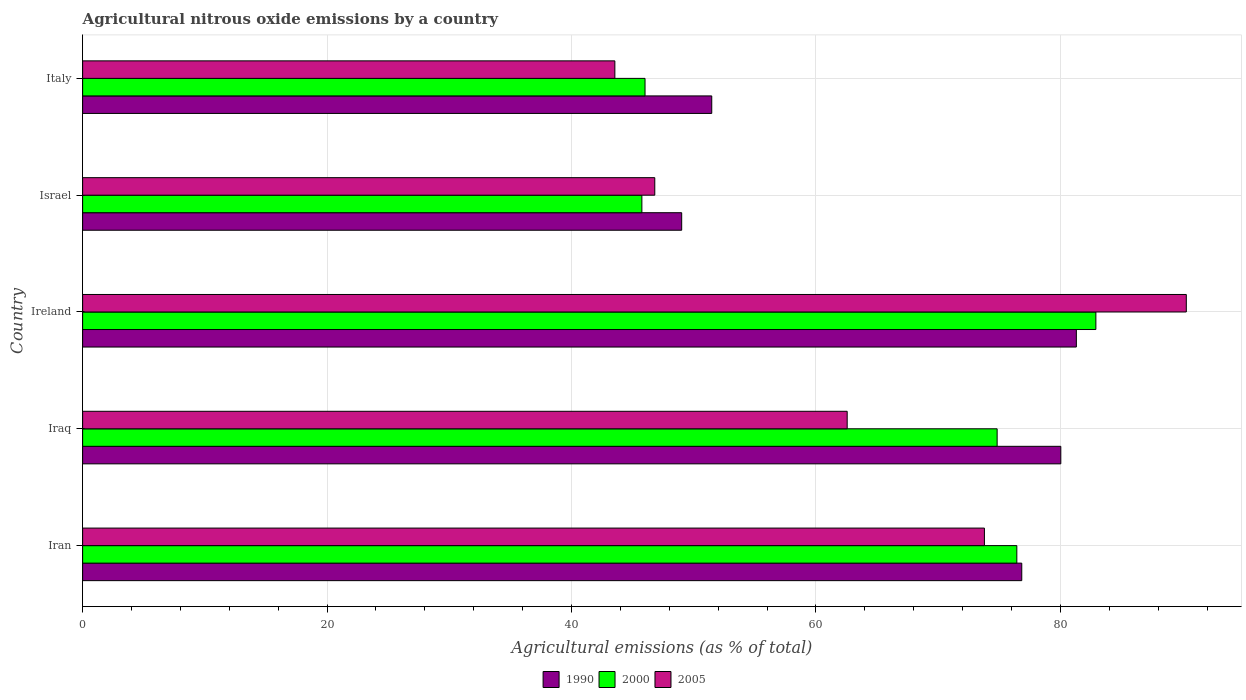How many different coloured bars are there?
Keep it short and to the point. 3. How many bars are there on the 3rd tick from the bottom?
Offer a very short reply. 3. What is the label of the 3rd group of bars from the top?
Ensure brevity in your answer.  Ireland. In how many cases, is the number of bars for a given country not equal to the number of legend labels?
Your answer should be compact. 0. What is the amount of agricultural nitrous oxide emitted in 1990 in Ireland?
Your answer should be very brief. 81.31. Across all countries, what is the maximum amount of agricultural nitrous oxide emitted in 2000?
Offer a very short reply. 82.91. Across all countries, what is the minimum amount of agricultural nitrous oxide emitted in 1990?
Your answer should be very brief. 49.02. In which country was the amount of agricultural nitrous oxide emitted in 2000 maximum?
Provide a succinct answer. Ireland. In which country was the amount of agricultural nitrous oxide emitted in 1990 minimum?
Your answer should be compact. Israel. What is the total amount of agricultural nitrous oxide emitted in 2000 in the graph?
Give a very brief answer. 325.96. What is the difference between the amount of agricultural nitrous oxide emitted in 2000 in Iraq and that in Israel?
Offer a very short reply. 29.07. What is the difference between the amount of agricultural nitrous oxide emitted in 2000 in Italy and the amount of agricultural nitrous oxide emitted in 2005 in Iran?
Your response must be concise. -27.77. What is the average amount of agricultural nitrous oxide emitted in 1990 per country?
Offer a very short reply. 67.74. What is the difference between the amount of agricultural nitrous oxide emitted in 2000 and amount of agricultural nitrous oxide emitted in 1990 in Iran?
Offer a very short reply. -0.4. In how many countries, is the amount of agricultural nitrous oxide emitted in 2000 greater than 24 %?
Give a very brief answer. 5. What is the ratio of the amount of agricultural nitrous oxide emitted in 2005 in Iran to that in Ireland?
Offer a terse response. 0.82. What is the difference between the highest and the second highest amount of agricultural nitrous oxide emitted in 1990?
Provide a succinct answer. 1.27. What is the difference between the highest and the lowest amount of agricultural nitrous oxide emitted in 1990?
Your response must be concise. 32.29. In how many countries, is the amount of agricultural nitrous oxide emitted in 2000 greater than the average amount of agricultural nitrous oxide emitted in 2000 taken over all countries?
Provide a short and direct response. 3. Are all the bars in the graph horizontal?
Offer a terse response. Yes. What is the difference between two consecutive major ticks on the X-axis?
Your response must be concise. 20. Are the values on the major ticks of X-axis written in scientific E-notation?
Provide a short and direct response. No. Does the graph contain any zero values?
Offer a very short reply. No. Does the graph contain grids?
Provide a succinct answer. Yes. How are the legend labels stacked?
Provide a succinct answer. Horizontal. What is the title of the graph?
Provide a short and direct response. Agricultural nitrous oxide emissions by a country. What is the label or title of the X-axis?
Your answer should be very brief. Agricultural emissions (as % of total). What is the label or title of the Y-axis?
Your answer should be very brief. Country. What is the Agricultural emissions (as % of total) of 1990 in Iran?
Provide a short and direct response. 76.84. What is the Agricultural emissions (as % of total) in 2000 in Iran?
Your response must be concise. 76.44. What is the Agricultural emissions (as % of total) of 2005 in Iran?
Give a very brief answer. 73.79. What is the Agricultural emissions (as % of total) of 1990 in Iraq?
Provide a short and direct response. 80.04. What is the Agricultural emissions (as % of total) in 2000 in Iraq?
Your answer should be very brief. 74.83. What is the Agricultural emissions (as % of total) of 2005 in Iraq?
Provide a succinct answer. 62.56. What is the Agricultural emissions (as % of total) in 1990 in Ireland?
Your response must be concise. 81.31. What is the Agricultural emissions (as % of total) in 2000 in Ireland?
Provide a succinct answer. 82.91. What is the Agricultural emissions (as % of total) in 2005 in Ireland?
Your answer should be very brief. 90.31. What is the Agricultural emissions (as % of total) of 1990 in Israel?
Offer a very short reply. 49.02. What is the Agricultural emissions (as % of total) of 2000 in Israel?
Provide a short and direct response. 45.76. What is the Agricultural emissions (as % of total) in 2005 in Israel?
Make the answer very short. 46.82. What is the Agricultural emissions (as % of total) in 1990 in Italy?
Your response must be concise. 51.48. What is the Agricultural emissions (as % of total) in 2000 in Italy?
Provide a short and direct response. 46.02. What is the Agricultural emissions (as % of total) of 2005 in Italy?
Offer a terse response. 43.55. Across all countries, what is the maximum Agricultural emissions (as % of total) in 1990?
Provide a succinct answer. 81.31. Across all countries, what is the maximum Agricultural emissions (as % of total) of 2000?
Offer a terse response. 82.91. Across all countries, what is the maximum Agricultural emissions (as % of total) of 2005?
Offer a very short reply. 90.31. Across all countries, what is the minimum Agricultural emissions (as % of total) in 1990?
Your response must be concise. 49.02. Across all countries, what is the minimum Agricultural emissions (as % of total) of 2000?
Make the answer very short. 45.76. Across all countries, what is the minimum Agricultural emissions (as % of total) of 2005?
Your answer should be compact. 43.55. What is the total Agricultural emissions (as % of total) of 1990 in the graph?
Your answer should be compact. 338.69. What is the total Agricultural emissions (as % of total) in 2000 in the graph?
Give a very brief answer. 325.96. What is the total Agricultural emissions (as % of total) of 2005 in the graph?
Make the answer very short. 317.02. What is the difference between the Agricultural emissions (as % of total) of 1990 in Iran and that in Iraq?
Your answer should be very brief. -3.19. What is the difference between the Agricultural emissions (as % of total) in 2000 in Iran and that in Iraq?
Your answer should be compact. 1.61. What is the difference between the Agricultural emissions (as % of total) in 2005 in Iran and that in Iraq?
Offer a terse response. 11.23. What is the difference between the Agricultural emissions (as % of total) in 1990 in Iran and that in Ireland?
Your response must be concise. -4.47. What is the difference between the Agricultural emissions (as % of total) in 2000 in Iran and that in Ireland?
Your answer should be compact. -6.47. What is the difference between the Agricultural emissions (as % of total) in 2005 in Iran and that in Ireland?
Ensure brevity in your answer.  -16.52. What is the difference between the Agricultural emissions (as % of total) in 1990 in Iran and that in Israel?
Ensure brevity in your answer.  27.83. What is the difference between the Agricultural emissions (as % of total) of 2000 in Iran and that in Israel?
Ensure brevity in your answer.  30.68. What is the difference between the Agricultural emissions (as % of total) in 2005 in Iran and that in Israel?
Provide a succinct answer. 26.97. What is the difference between the Agricultural emissions (as % of total) in 1990 in Iran and that in Italy?
Provide a short and direct response. 25.37. What is the difference between the Agricultural emissions (as % of total) of 2000 in Iran and that in Italy?
Offer a terse response. 30.42. What is the difference between the Agricultural emissions (as % of total) of 2005 in Iran and that in Italy?
Provide a succinct answer. 30.24. What is the difference between the Agricultural emissions (as % of total) in 1990 in Iraq and that in Ireland?
Give a very brief answer. -1.27. What is the difference between the Agricultural emissions (as % of total) in 2000 in Iraq and that in Ireland?
Offer a very short reply. -8.08. What is the difference between the Agricultural emissions (as % of total) of 2005 in Iraq and that in Ireland?
Provide a short and direct response. -27.75. What is the difference between the Agricultural emissions (as % of total) in 1990 in Iraq and that in Israel?
Make the answer very short. 31.02. What is the difference between the Agricultural emissions (as % of total) in 2000 in Iraq and that in Israel?
Your answer should be compact. 29.07. What is the difference between the Agricultural emissions (as % of total) in 2005 in Iraq and that in Israel?
Provide a short and direct response. 15.74. What is the difference between the Agricultural emissions (as % of total) in 1990 in Iraq and that in Italy?
Make the answer very short. 28.56. What is the difference between the Agricultural emissions (as % of total) of 2000 in Iraq and that in Italy?
Provide a short and direct response. 28.81. What is the difference between the Agricultural emissions (as % of total) in 2005 in Iraq and that in Italy?
Provide a short and direct response. 19.01. What is the difference between the Agricultural emissions (as % of total) of 1990 in Ireland and that in Israel?
Your answer should be very brief. 32.29. What is the difference between the Agricultural emissions (as % of total) in 2000 in Ireland and that in Israel?
Keep it short and to the point. 37.15. What is the difference between the Agricultural emissions (as % of total) of 2005 in Ireland and that in Israel?
Keep it short and to the point. 43.49. What is the difference between the Agricultural emissions (as % of total) of 1990 in Ireland and that in Italy?
Keep it short and to the point. 29.83. What is the difference between the Agricultural emissions (as % of total) in 2000 in Ireland and that in Italy?
Your answer should be compact. 36.89. What is the difference between the Agricultural emissions (as % of total) of 2005 in Ireland and that in Italy?
Your response must be concise. 46.76. What is the difference between the Agricultural emissions (as % of total) of 1990 in Israel and that in Italy?
Your answer should be compact. -2.46. What is the difference between the Agricultural emissions (as % of total) in 2000 in Israel and that in Italy?
Keep it short and to the point. -0.26. What is the difference between the Agricultural emissions (as % of total) in 2005 in Israel and that in Italy?
Offer a very short reply. 3.27. What is the difference between the Agricultural emissions (as % of total) of 1990 in Iran and the Agricultural emissions (as % of total) of 2000 in Iraq?
Your answer should be compact. 2.02. What is the difference between the Agricultural emissions (as % of total) in 1990 in Iran and the Agricultural emissions (as % of total) in 2005 in Iraq?
Your answer should be compact. 14.29. What is the difference between the Agricultural emissions (as % of total) in 2000 in Iran and the Agricultural emissions (as % of total) in 2005 in Iraq?
Offer a terse response. 13.88. What is the difference between the Agricultural emissions (as % of total) of 1990 in Iran and the Agricultural emissions (as % of total) of 2000 in Ireland?
Keep it short and to the point. -6.06. What is the difference between the Agricultural emissions (as % of total) in 1990 in Iran and the Agricultural emissions (as % of total) in 2005 in Ireland?
Offer a very short reply. -13.46. What is the difference between the Agricultural emissions (as % of total) of 2000 in Iran and the Agricultural emissions (as % of total) of 2005 in Ireland?
Your response must be concise. -13.87. What is the difference between the Agricultural emissions (as % of total) in 1990 in Iran and the Agricultural emissions (as % of total) in 2000 in Israel?
Provide a succinct answer. 31.08. What is the difference between the Agricultural emissions (as % of total) of 1990 in Iran and the Agricultural emissions (as % of total) of 2005 in Israel?
Your answer should be compact. 30.03. What is the difference between the Agricultural emissions (as % of total) in 2000 in Iran and the Agricultural emissions (as % of total) in 2005 in Israel?
Make the answer very short. 29.62. What is the difference between the Agricultural emissions (as % of total) in 1990 in Iran and the Agricultural emissions (as % of total) in 2000 in Italy?
Keep it short and to the point. 30.83. What is the difference between the Agricultural emissions (as % of total) in 1990 in Iran and the Agricultural emissions (as % of total) in 2005 in Italy?
Keep it short and to the point. 33.3. What is the difference between the Agricultural emissions (as % of total) in 2000 in Iran and the Agricultural emissions (as % of total) in 2005 in Italy?
Your answer should be compact. 32.89. What is the difference between the Agricultural emissions (as % of total) in 1990 in Iraq and the Agricultural emissions (as % of total) in 2000 in Ireland?
Keep it short and to the point. -2.87. What is the difference between the Agricultural emissions (as % of total) of 1990 in Iraq and the Agricultural emissions (as % of total) of 2005 in Ireland?
Your response must be concise. -10.27. What is the difference between the Agricultural emissions (as % of total) in 2000 in Iraq and the Agricultural emissions (as % of total) in 2005 in Ireland?
Offer a very short reply. -15.48. What is the difference between the Agricultural emissions (as % of total) of 1990 in Iraq and the Agricultural emissions (as % of total) of 2000 in Israel?
Give a very brief answer. 34.28. What is the difference between the Agricultural emissions (as % of total) in 1990 in Iraq and the Agricultural emissions (as % of total) in 2005 in Israel?
Make the answer very short. 33.22. What is the difference between the Agricultural emissions (as % of total) in 2000 in Iraq and the Agricultural emissions (as % of total) in 2005 in Israel?
Make the answer very short. 28.01. What is the difference between the Agricultural emissions (as % of total) in 1990 in Iraq and the Agricultural emissions (as % of total) in 2000 in Italy?
Keep it short and to the point. 34.02. What is the difference between the Agricultural emissions (as % of total) in 1990 in Iraq and the Agricultural emissions (as % of total) in 2005 in Italy?
Provide a succinct answer. 36.49. What is the difference between the Agricultural emissions (as % of total) of 2000 in Iraq and the Agricultural emissions (as % of total) of 2005 in Italy?
Ensure brevity in your answer.  31.28. What is the difference between the Agricultural emissions (as % of total) of 1990 in Ireland and the Agricultural emissions (as % of total) of 2000 in Israel?
Keep it short and to the point. 35.55. What is the difference between the Agricultural emissions (as % of total) in 1990 in Ireland and the Agricultural emissions (as % of total) in 2005 in Israel?
Your answer should be very brief. 34.49. What is the difference between the Agricultural emissions (as % of total) of 2000 in Ireland and the Agricultural emissions (as % of total) of 2005 in Israel?
Your answer should be compact. 36.09. What is the difference between the Agricultural emissions (as % of total) of 1990 in Ireland and the Agricultural emissions (as % of total) of 2000 in Italy?
Offer a very short reply. 35.29. What is the difference between the Agricultural emissions (as % of total) of 1990 in Ireland and the Agricultural emissions (as % of total) of 2005 in Italy?
Provide a succinct answer. 37.76. What is the difference between the Agricultural emissions (as % of total) of 2000 in Ireland and the Agricultural emissions (as % of total) of 2005 in Italy?
Keep it short and to the point. 39.36. What is the difference between the Agricultural emissions (as % of total) in 1990 in Israel and the Agricultural emissions (as % of total) in 2000 in Italy?
Give a very brief answer. 3. What is the difference between the Agricultural emissions (as % of total) in 1990 in Israel and the Agricultural emissions (as % of total) in 2005 in Italy?
Offer a terse response. 5.47. What is the difference between the Agricultural emissions (as % of total) of 2000 in Israel and the Agricultural emissions (as % of total) of 2005 in Italy?
Offer a terse response. 2.21. What is the average Agricultural emissions (as % of total) of 1990 per country?
Provide a short and direct response. 67.74. What is the average Agricultural emissions (as % of total) in 2000 per country?
Your answer should be compact. 65.19. What is the average Agricultural emissions (as % of total) of 2005 per country?
Your response must be concise. 63.4. What is the difference between the Agricultural emissions (as % of total) in 1990 and Agricultural emissions (as % of total) in 2000 in Iran?
Make the answer very short. 0.4. What is the difference between the Agricultural emissions (as % of total) in 1990 and Agricultural emissions (as % of total) in 2005 in Iran?
Your answer should be very brief. 3.06. What is the difference between the Agricultural emissions (as % of total) of 2000 and Agricultural emissions (as % of total) of 2005 in Iran?
Provide a succinct answer. 2.65. What is the difference between the Agricultural emissions (as % of total) of 1990 and Agricultural emissions (as % of total) of 2000 in Iraq?
Make the answer very short. 5.21. What is the difference between the Agricultural emissions (as % of total) of 1990 and Agricultural emissions (as % of total) of 2005 in Iraq?
Give a very brief answer. 17.48. What is the difference between the Agricultural emissions (as % of total) in 2000 and Agricultural emissions (as % of total) in 2005 in Iraq?
Your answer should be very brief. 12.27. What is the difference between the Agricultural emissions (as % of total) in 1990 and Agricultural emissions (as % of total) in 2000 in Ireland?
Offer a very short reply. -1.6. What is the difference between the Agricultural emissions (as % of total) in 1990 and Agricultural emissions (as % of total) in 2005 in Ireland?
Provide a succinct answer. -9. What is the difference between the Agricultural emissions (as % of total) of 2000 and Agricultural emissions (as % of total) of 2005 in Ireland?
Provide a succinct answer. -7.4. What is the difference between the Agricultural emissions (as % of total) of 1990 and Agricultural emissions (as % of total) of 2000 in Israel?
Provide a succinct answer. 3.26. What is the difference between the Agricultural emissions (as % of total) of 1990 and Agricultural emissions (as % of total) of 2005 in Israel?
Offer a terse response. 2.2. What is the difference between the Agricultural emissions (as % of total) in 2000 and Agricultural emissions (as % of total) in 2005 in Israel?
Your answer should be compact. -1.06. What is the difference between the Agricultural emissions (as % of total) in 1990 and Agricultural emissions (as % of total) in 2000 in Italy?
Offer a very short reply. 5.46. What is the difference between the Agricultural emissions (as % of total) of 1990 and Agricultural emissions (as % of total) of 2005 in Italy?
Give a very brief answer. 7.93. What is the difference between the Agricultural emissions (as % of total) in 2000 and Agricultural emissions (as % of total) in 2005 in Italy?
Give a very brief answer. 2.47. What is the ratio of the Agricultural emissions (as % of total) of 1990 in Iran to that in Iraq?
Offer a very short reply. 0.96. What is the ratio of the Agricultural emissions (as % of total) of 2000 in Iran to that in Iraq?
Keep it short and to the point. 1.02. What is the ratio of the Agricultural emissions (as % of total) of 2005 in Iran to that in Iraq?
Keep it short and to the point. 1.18. What is the ratio of the Agricultural emissions (as % of total) of 1990 in Iran to that in Ireland?
Your answer should be very brief. 0.95. What is the ratio of the Agricultural emissions (as % of total) of 2000 in Iran to that in Ireland?
Your answer should be compact. 0.92. What is the ratio of the Agricultural emissions (as % of total) of 2005 in Iran to that in Ireland?
Your answer should be compact. 0.82. What is the ratio of the Agricultural emissions (as % of total) of 1990 in Iran to that in Israel?
Your answer should be compact. 1.57. What is the ratio of the Agricultural emissions (as % of total) in 2000 in Iran to that in Israel?
Ensure brevity in your answer.  1.67. What is the ratio of the Agricultural emissions (as % of total) in 2005 in Iran to that in Israel?
Give a very brief answer. 1.58. What is the ratio of the Agricultural emissions (as % of total) of 1990 in Iran to that in Italy?
Provide a succinct answer. 1.49. What is the ratio of the Agricultural emissions (as % of total) in 2000 in Iran to that in Italy?
Make the answer very short. 1.66. What is the ratio of the Agricultural emissions (as % of total) of 2005 in Iran to that in Italy?
Provide a succinct answer. 1.69. What is the ratio of the Agricultural emissions (as % of total) in 1990 in Iraq to that in Ireland?
Give a very brief answer. 0.98. What is the ratio of the Agricultural emissions (as % of total) in 2000 in Iraq to that in Ireland?
Provide a succinct answer. 0.9. What is the ratio of the Agricultural emissions (as % of total) in 2005 in Iraq to that in Ireland?
Offer a very short reply. 0.69. What is the ratio of the Agricultural emissions (as % of total) in 1990 in Iraq to that in Israel?
Provide a succinct answer. 1.63. What is the ratio of the Agricultural emissions (as % of total) in 2000 in Iraq to that in Israel?
Your answer should be very brief. 1.64. What is the ratio of the Agricultural emissions (as % of total) in 2005 in Iraq to that in Israel?
Ensure brevity in your answer.  1.34. What is the ratio of the Agricultural emissions (as % of total) of 1990 in Iraq to that in Italy?
Make the answer very short. 1.55. What is the ratio of the Agricultural emissions (as % of total) in 2000 in Iraq to that in Italy?
Your answer should be compact. 1.63. What is the ratio of the Agricultural emissions (as % of total) of 2005 in Iraq to that in Italy?
Give a very brief answer. 1.44. What is the ratio of the Agricultural emissions (as % of total) in 1990 in Ireland to that in Israel?
Your answer should be compact. 1.66. What is the ratio of the Agricultural emissions (as % of total) of 2000 in Ireland to that in Israel?
Offer a terse response. 1.81. What is the ratio of the Agricultural emissions (as % of total) of 2005 in Ireland to that in Israel?
Your answer should be very brief. 1.93. What is the ratio of the Agricultural emissions (as % of total) of 1990 in Ireland to that in Italy?
Give a very brief answer. 1.58. What is the ratio of the Agricultural emissions (as % of total) in 2000 in Ireland to that in Italy?
Give a very brief answer. 1.8. What is the ratio of the Agricultural emissions (as % of total) of 2005 in Ireland to that in Italy?
Your response must be concise. 2.07. What is the ratio of the Agricultural emissions (as % of total) of 1990 in Israel to that in Italy?
Offer a terse response. 0.95. What is the ratio of the Agricultural emissions (as % of total) in 2000 in Israel to that in Italy?
Your response must be concise. 0.99. What is the ratio of the Agricultural emissions (as % of total) in 2005 in Israel to that in Italy?
Provide a succinct answer. 1.07. What is the difference between the highest and the second highest Agricultural emissions (as % of total) in 1990?
Your answer should be compact. 1.27. What is the difference between the highest and the second highest Agricultural emissions (as % of total) in 2000?
Your answer should be compact. 6.47. What is the difference between the highest and the second highest Agricultural emissions (as % of total) of 2005?
Offer a very short reply. 16.52. What is the difference between the highest and the lowest Agricultural emissions (as % of total) in 1990?
Make the answer very short. 32.29. What is the difference between the highest and the lowest Agricultural emissions (as % of total) in 2000?
Offer a very short reply. 37.15. What is the difference between the highest and the lowest Agricultural emissions (as % of total) of 2005?
Ensure brevity in your answer.  46.76. 